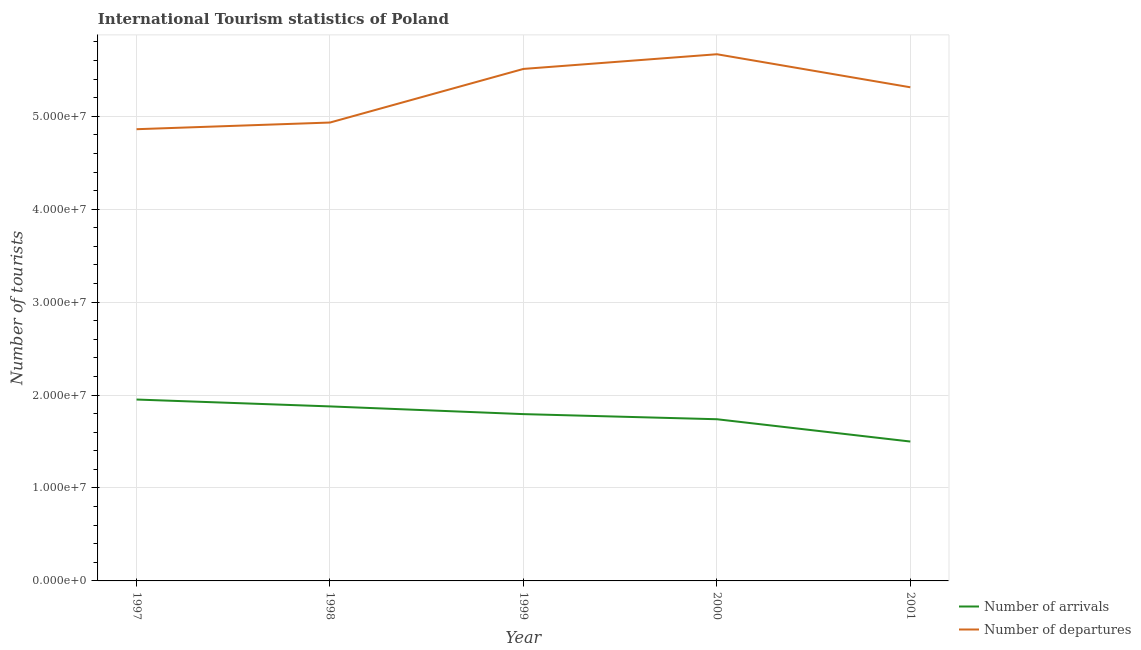Does the line corresponding to number of tourist arrivals intersect with the line corresponding to number of tourist departures?
Offer a terse response. No. Is the number of lines equal to the number of legend labels?
Provide a short and direct response. Yes. What is the number of tourist departures in 1997?
Ensure brevity in your answer.  4.86e+07. Across all years, what is the maximum number of tourist arrivals?
Provide a succinct answer. 1.95e+07. Across all years, what is the minimum number of tourist arrivals?
Offer a very short reply. 1.50e+07. In which year was the number of tourist departures maximum?
Offer a very short reply. 2000. In which year was the number of tourist departures minimum?
Provide a short and direct response. 1997. What is the total number of tourist arrivals in the graph?
Ensure brevity in your answer.  8.86e+07. What is the difference between the number of tourist departures in 1998 and that in 1999?
Your response must be concise. -5.77e+06. What is the difference between the number of tourist departures in 1998 and the number of tourist arrivals in 1997?
Offer a very short reply. 2.98e+07. What is the average number of tourist departures per year?
Give a very brief answer. 5.26e+07. In the year 1999, what is the difference between the number of tourist arrivals and number of tourist departures?
Provide a succinct answer. -3.71e+07. What is the ratio of the number of tourist departures in 1998 to that in 2001?
Make the answer very short. 0.93. What is the difference between the highest and the second highest number of tourist arrivals?
Your answer should be very brief. 7.40e+05. What is the difference between the highest and the lowest number of tourist departures?
Ensure brevity in your answer.  8.07e+06. In how many years, is the number of tourist departures greater than the average number of tourist departures taken over all years?
Give a very brief answer. 3. Is the sum of the number of tourist arrivals in 1997 and 1998 greater than the maximum number of tourist departures across all years?
Offer a terse response. No. Is the number of tourist departures strictly less than the number of tourist arrivals over the years?
Keep it short and to the point. No. Are the values on the major ticks of Y-axis written in scientific E-notation?
Offer a very short reply. Yes. Does the graph contain any zero values?
Your answer should be compact. No. Where does the legend appear in the graph?
Your response must be concise. Bottom right. How many legend labels are there?
Provide a succinct answer. 2. How are the legend labels stacked?
Your response must be concise. Vertical. What is the title of the graph?
Your answer should be very brief. International Tourism statistics of Poland. What is the label or title of the Y-axis?
Offer a very short reply. Number of tourists. What is the Number of tourists in Number of arrivals in 1997?
Provide a short and direct response. 1.95e+07. What is the Number of tourists of Number of departures in 1997?
Give a very brief answer. 4.86e+07. What is the Number of tourists in Number of arrivals in 1998?
Your answer should be compact. 1.88e+07. What is the Number of tourists of Number of departures in 1998?
Offer a very short reply. 4.93e+07. What is the Number of tourists in Number of arrivals in 1999?
Give a very brief answer. 1.80e+07. What is the Number of tourists of Number of departures in 1999?
Your answer should be compact. 5.51e+07. What is the Number of tourists of Number of arrivals in 2000?
Make the answer very short. 1.74e+07. What is the Number of tourists of Number of departures in 2000?
Provide a short and direct response. 5.67e+07. What is the Number of tourists of Number of arrivals in 2001?
Ensure brevity in your answer.  1.50e+07. What is the Number of tourists of Number of departures in 2001?
Provide a succinct answer. 5.31e+07. Across all years, what is the maximum Number of tourists in Number of arrivals?
Provide a short and direct response. 1.95e+07. Across all years, what is the maximum Number of tourists of Number of departures?
Offer a terse response. 5.67e+07. Across all years, what is the minimum Number of tourists of Number of arrivals?
Your answer should be compact. 1.50e+07. Across all years, what is the minimum Number of tourists in Number of departures?
Give a very brief answer. 4.86e+07. What is the total Number of tourists of Number of arrivals in the graph?
Ensure brevity in your answer.  8.86e+07. What is the total Number of tourists of Number of departures in the graph?
Keep it short and to the point. 2.63e+08. What is the difference between the Number of tourists of Number of arrivals in 1997 and that in 1998?
Make the answer very short. 7.40e+05. What is the difference between the Number of tourists of Number of departures in 1997 and that in 1998?
Provide a short and direct response. -7.18e+05. What is the difference between the Number of tourists of Number of arrivals in 1997 and that in 1999?
Your answer should be compact. 1.57e+06. What is the difference between the Number of tourists of Number of departures in 1997 and that in 1999?
Ensure brevity in your answer.  -6.49e+06. What is the difference between the Number of tourists of Number of arrivals in 1997 and that in 2000?
Offer a terse response. 2.12e+06. What is the difference between the Number of tourists in Number of departures in 1997 and that in 2000?
Provide a short and direct response. -8.07e+06. What is the difference between the Number of tourists of Number of arrivals in 1997 and that in 2001?
Give a very brief answer. 4.52e+06. What is the difference between the Number of tourists of Number of departures in 1997 and that in 2001?
Your answer should be very brief. -4.51e+06. What is the difference between the Number of tourists of Number of arrivals in 1998 and that in 1999?
Offer a very short reply. 8.30e+05. What is the difference between the Number of tourists of Number of departures in 1998 and that in 1999?
Your answer should be very brief. -5.77e+06. What is the difference between the Number of tourists of Number of arrivals in 1998 and that in 2000?
Give a very brief answer. 1.38e+06. What is the difference between the Number of tourists of Number of departures in 1998 and that in 2000?
Your answer should be compact. -7.35e+06. What is the difference between the Number of tourists in Number of arrivals in 1998 and that in 2001?
Your answer should be very brief. 3.78e+06. What is the difference between the Number of tourists of Number of departures in 1998 and that in 2001?
Make the answer very short. -3.79e+06. What is the difference between the Number of tourists in Number of departures in 1999 and that in 2000?
Your answer should be compact. -1.58e+06. What is the difference between the Number of tourists in Number of arrivals in 1999 and that in 2001?
Provide a succinct answer. 2.95e+06. What is the difference between the Number of tourists of Number of departures in 1999 and that in 2001?
Your answer should be very brief. 1.98e+06. What is the difference between the Number of tourists in Number of arrivals in 2000 and that in 2001?
Offer a terse response. 2.40e+06. What is the difference between the Number of tourists in Number of departures in 2000 and that in 2001?
Ensure brevity in your answer.  3.56e+06. What is the difference between the Number of tourists of Number of arrivals in 1997 and the Number of tourists of Number of departures in 1998?
Ensure brevity in your answer.  -2.98e+07. What is the difference between the Number of tourists of Number of arrivals in 1997 and the Number of tourists of Number of departures in 1999?
Ensure brevity in your answer.  -3.56e+07. What is the difference between the Number of tourists of Number of arrivals in 1997 and the Number of tourists of Number of departures in 2000?
Make the answer very short. -3.72e+07. What is the difference between the Number of tourists in Number of arrivals in 1997 and the Number of tourists in Number of departures in 2001?
Ensure brevity in your answer.  -3.36e+07. What is the difference between the Number of tourists in Number of arrivals in 1998 and the Number of tourists in Number of departures in 1999?
Offer a terse response. -3.63e+07. What is the difference between the Number of tourists of Number of arrivals in 1998 and the Number of tourists of Number of departures in 2000?
Offer a very short reply. -3.79e+07. What is the difference between the Number of tourists in Number of arrivals in 1998 and the Number of tourists in Number of departures in 2001?
Your answer should be compact. -3.43e+07. What is the difference between the Number of tourists in Number of arrivals in 1999 and the Number of tourists in Number of departures in 2000?
Your answer should be compact. -3.87e+07. What is the difference between the Number of tourists in Number of arrivals in 1999 and the Number of tourists in Number of departures in 2001?
Offer a terse response. -3.52e+07. What is the difference between the Number of tourists of Number of arrivals in 2000 and the Number of tourists of Number of departures in 2001?
Provide a succinct answer. -3.57e+07. What is the average Number of tourists in Number of arrivals per year?
Keep it short and to the point. 1.77e+07. What is the average Number of tourists in Number of departures per year?
Offer a very short reply. 5.26e+07. In the year 1997, what is the difference between the Number of tourists in Number of arrivals and Number of tourists in Number of departures?
Offer a very short reply. -2.91e+07. In the year 1998, what is the difference between the Number of tourists of Number of arrivals and Number of tourists of Number of departures?
Ensure brevity in your answer.  -3.05e+07. In the year 1999, what is the difference between the Number of tourists of Number of arrivals and Number of tourists of Number of departures?
Keep it short and to the point. -3.71e+07. In the year 2000, what is the difference between the Number of tourists in Number of arrivals and Number of tourists in Number of departures?
Offer a very short reply. -3.93e+07. In the year 2001, what is the difference between the Number of tourists in Number of arrivals and Number of tourists in Number of departures?
Keep it short and to the point. -3.81e+07. What is the ratio of the Number of tourists of Number of arrivals in 1997 to that in 1998?
Give a very brief answer. 1.04. What is the ratio of the Number of tourists of Number of departures in 1997 to that in 1998?
Make the answer very short. 0.99. What is the ratio of the Number of tourists in Number of arrivals in 1997 to that in 1999?
Offer a terse response. 1.09. What is the ratio of the Number of tourists in Number of departures in 1997 to that in 1999?
Keep it short and to the point. 0.88. What is the ratio of the Number of tourists of Number of arrivals in 1997 to that in 2000?
Give a very brief answer. 1.12. What is the ratio of the Number of tourists of Number of departures in 1997 to that in 2000?
Make the answer very short. 0.86. What is the ratio of the Number of tourists in Number of arrivals in 1997 to that in 2001?
Ensure brevity in your answer.  1.3. What is the ratio of the Number of tourists of Number of departures in 1997 to that in 2001?
Your answer should be compact. 0.92. What is the ratio of the Number of tourists of Number of arrivals in 1998 to that in 1999?
Your answer should be very brief. 1.05. What is the ratio of the Number of tourists in Number of departures in 1998 to that in 1999?
Make the answer very short. 0.9. What is the ratio of the Number of tourists of Number of arrivals in 1998 to that in 2000?
Provide a succinct answer. 1.08. What is the ratio of the Number of tourists of Number of departures in 1998 to that in 2000?
Make the answer very short. 0.87. What is the ratio of the Number of tourists in Number of arrivals in 1998 to that in 2001?
Provide a short and direct response. 1.25. What is the ratio of the Number of tourists in Number of arrivals in 1999 to that in 2000?
Your answer should be compact. 1.03. What is the ratio of the Number of tourists of Number of departures in 1999 to that in 2000?
Offer a terse response. 0.97. What is the ratio of the Number of tourists of Number of arrivals in 1999 to that in 2001?
Offer a very short reply. 1.2. What is the ratio of the Number of tourists of Number of departures in 1999 to that in 2001?
Your response must be concise. 1.04. What is the ratio of the Number of tourists of Number of arrivals in 2000 to that in 2001?
Offer a very short reply. 1.16. What is the ratio of the Number of tourists in Number of departures in 2000 to that in 2001?
Provide a short and direct response. 1.07. What is the difference between the highest and the second highest Number of tourists in Number of arrivals?
Your response must be concise. 7.40e+05. What is the difference between the highest and the second highest Number of tourists of Number of departures?
Make the answer very short. 1.58e+06. What is the difference between the highest and the lowest Number of tourists in Number of arrivals?
Offer a very short reply. 4.52e+06. What is the difference between the highest and the lowest Number of tourists of Number of departures?
Offer a very short reply. 8.07e+06. 